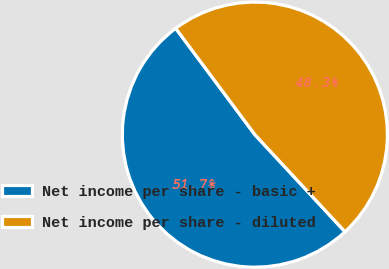Convert chart to OTSL. <chart><loc_0><loc_0><loc_500><loc_500><pie_chart><fcel>Net income per share - basic +<fcel>Net income per share - diluted<nl><fcel>51.72%<fcel>48.28%<nl></chart> 